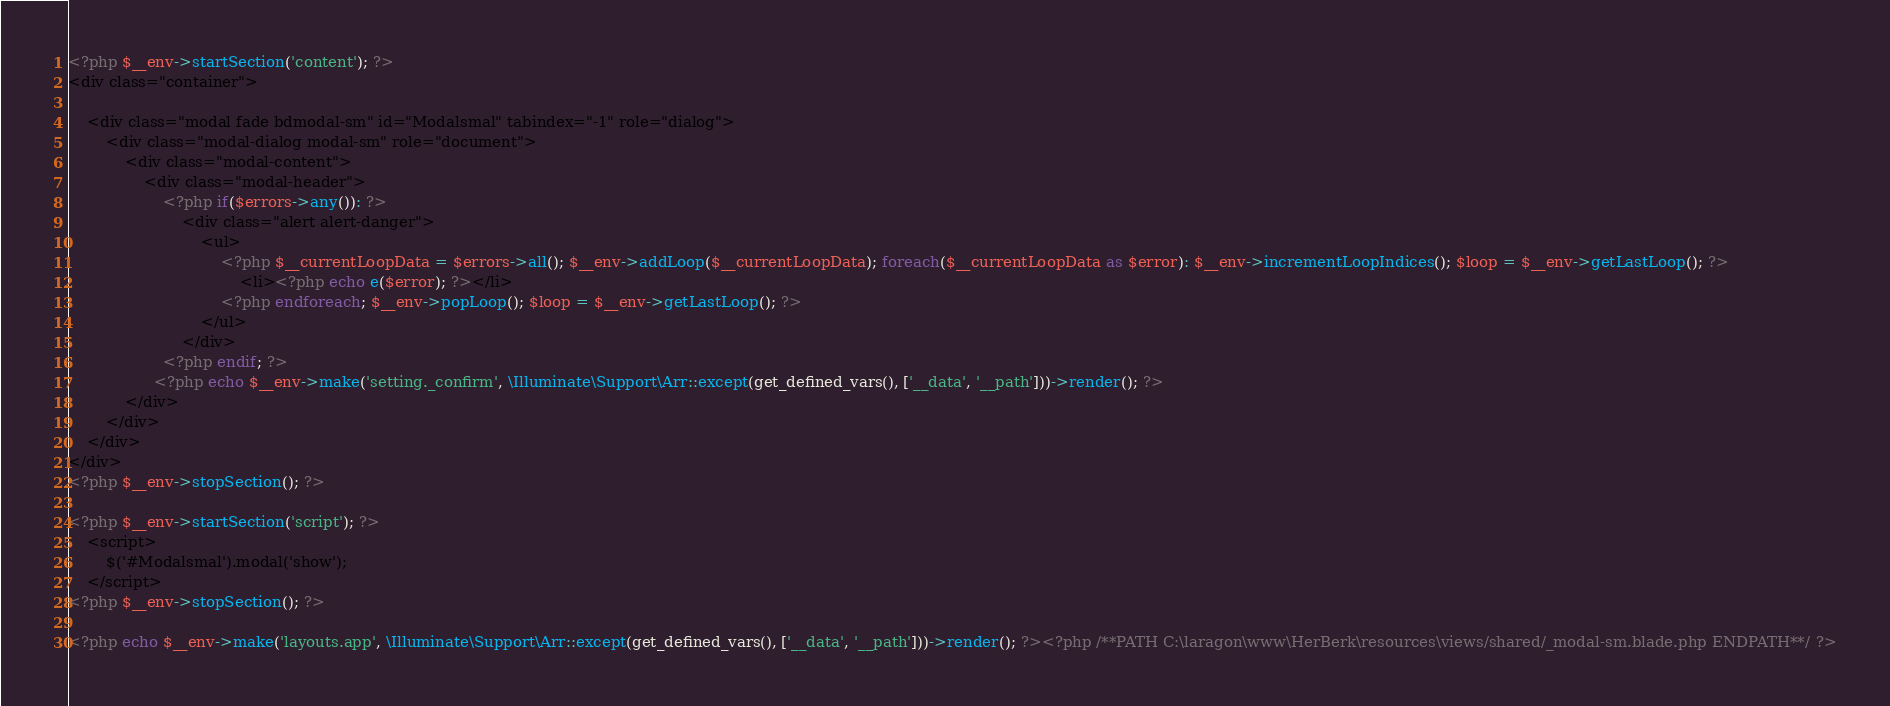Convert code to text. <code><loc_0><loc_0><loc_500><loc_500><_PHP_><?php $__env->startSection('content'); ?>
<div class="container">

    <div class="modal fade bdmodal-sm" id="Modalsmal" tabindex="-1" role="dialog">
        <div class="modal-dialog modal-sm" role="document">
            <div class="modal-content">
                <div class="modal-header">
                    <?php if($errors->any()): ?>
                        <div class="alert alert-danger">
                            <ul>
                                <?php $__currentLoopData = $errors->all(); $__env->addLoop($__currentLoopData); foreach($__currentLoopData as $error): $__env->incrementLoopIndices(); $loop = $__env->getLastLoop(); ?>
                                    <li><?php echo e($error); ?></li>
                                <?php endforeach; $__env->popLoop(); $loop = $__env->getLastLoop(); ?>
                            </ul>
                        </div>
                    <?php endif; ?>
                  <?php echo $__env->make('setting._confirm', \Illuminate\Support\Arr::except(get_defined_vars(), ['__data', '__path']))->render(); ?>
            </div>
        </div>
    </div>
</div>
<?php $__env->stopSection(); ?>

<?php $__env->startSection('script'); ?>
    <script>
        $('#Modalsmal').modal('show');
    </script>
<?php $__env->stopSection(); ?>

<?php echo $__env->make('layouts.app', \Illuminate\Support\Arr::except(get_defined_vars(), ['__data', '__path']))->render(); ?><?php /**PATH C:\laragon\www\HerBerk\resources\views/shared/_modal-sm.blade.php ENDPATH**/ ?></code> 